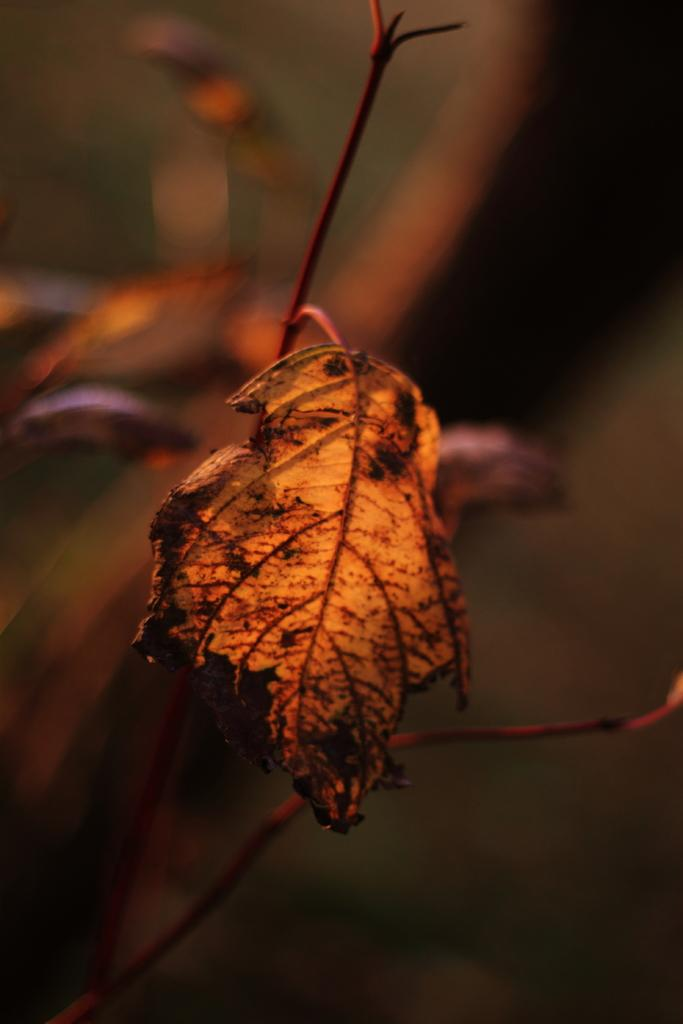What can be observed about the image's appearance? The image is edited. What is the main subject in the image? There is a leaf in the middle of the image. How is the background of the image depicted? The background of the image is blurred. How many snakes are slithering around the leaf in the image? There are no snakes present in the image; it features a leaf with a blurred background. What type of memory is being stored in the leaf in the image? The image does not depict any memory being stored in the leaf; it is simply a leaf with a blurred background. 